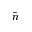<formula> <loc_0><loc_0><loc_500><loc_500>\hat { n }</formula> 